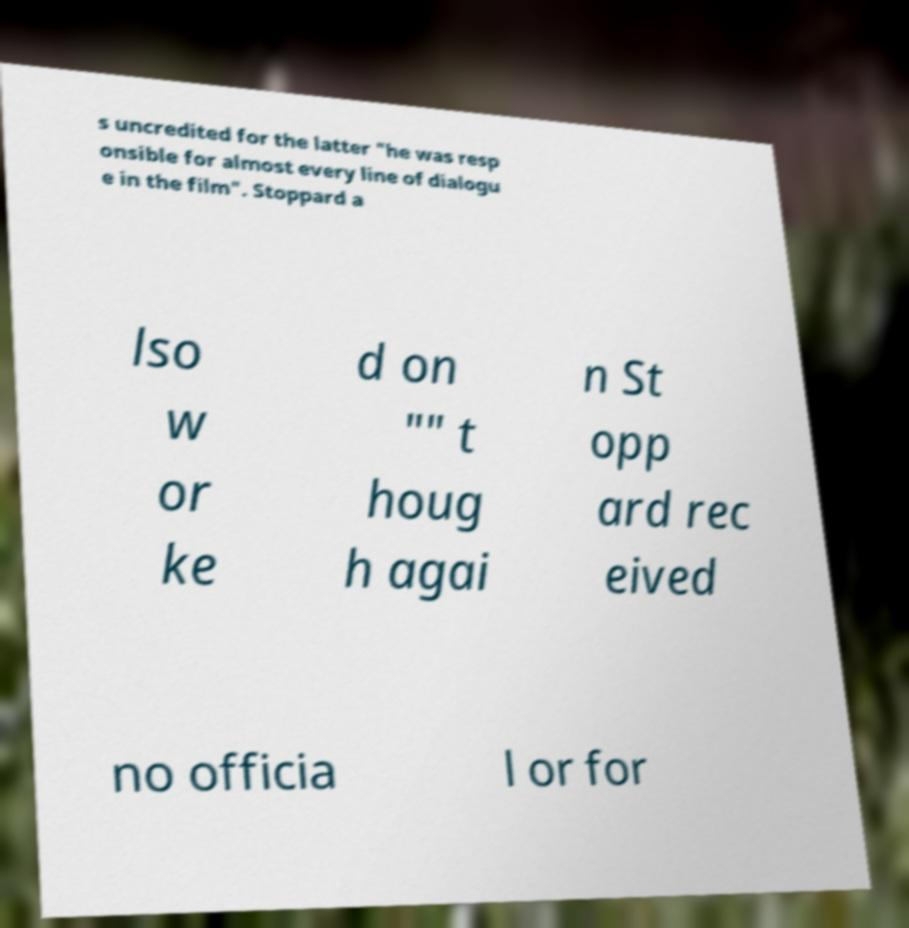Please read and relay the text visible in this image. What does it say? s uncredited for the latter "he was resp onsible for almost every line of dialogu e in the film". Stoppard a lso w or ke d on "" t houg h agai n St opp ard rec eived no officia l or for 